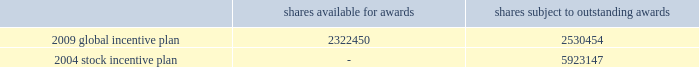Tax returns for 2001 and beyond are open for examination under statute .
Currently , unrecognized tax benefits are not expected to change significantly over the next 12 months .
19 .
Stock-based and other management compensation plans in april 2009 , the company approved a global incentive plan which replaces the company 2019s 2004 stock incentive plan .
The 2009 global incentive plan ( 201cgip 201d ) enables the compensation committee of the board of directors to award incentive and nonqualified stock options , stock appreciation rights , shares of series a common stock , restricted stock , restricted stock units ( 201crsus 201d ) and incentive bonuses ( which may be paid in cash or stock or a combination thereof ) , any of which may be performance-based , with vesting and other award provisions that provide effective incentive to company employees ( including officers ) , non-management directors and other service providers .
Under the 2009 gip , the company no longer can grant rsus with the right to participate in dividends or dividend equivalents .
The maximum number of shares that may be issued under the 2009 gip is equal to 5350000 shares plus ( a ) any shares of series a common stock that remain available for issuance under the 2004 stock incentive plan ( 201csip 201d ) ( not including any shares of series a common stock that are subject to outstanding awards under the 2004 sip or any shares of series a common stock that were issued pursuant to awards under the 2004 sip ) and ( b ) any awards under the 2004 stock incentive plan that remain outstanding that cease for any reason to be subject to such awards ( other than by reason of exercise or settlement of the award to the extent that such award is exercised for or settled in vested and non-forfeitable shares ) .
As of december 31 , 2010 , total shares available for awards and total shares subject to outstanding awards are as follows : shares available for awards shares subject to outstanding awards .
Upon the termination of a participant 2019s employment with the company by reason of death or disability or by the company without cause ( as defined in the respective award agreements ) , an award in amount equal to ( i ) the value of the award granted multiplied by ( ii ) a fraction , ( x ) the numerator of which is the number of full months between grant date and the date of such termination , and ( y ) the denominator of which is the term of the award , such product to be rounded down to the nearest whole number , and reduced by ( iii ) the value of any award that previously vested , shall immediately vest and become payable to the participant .
Upon the termination of a participant 2019s employment with the company for any other reason , any unvested portion of the award shall be forfeited and cancelled without consideration .
There was $ 19 million and $ 0 million of tax benefit realized from stock option exercises and vesting of rsus during the years ended december 31 , 2010 and 2009 , respectively .
During the year ended december 31 , 2008 the company reversed $ 8 million of the $ 19 million tax benefit that was realized during the year ended december 31 , 2007 .
Deferred compensation in april 2007 , certain participants in the company 2019s 2004 deferred compensation plan elected to participate in a revised program , which includes both cash awards and restricted stock units ( see restricted stock units below ) .
Based on participation in the revised program , the company expensed $ 9 million , $ 10 million and $ 8 million during the years ended december 31 , 2010 , 2009 and 2008 , respectively , related to the revised program and made payments of $ 4 million during the year ended december 31 , 2010 to participants who left the company and $ 28 million to active employees during december 2010 .
As of december 31 , 2010 , $ 1 million remains to be paid during 2011 under the revised program .
As of december 31 , 2009 , there was no deferred compensation payable remaining associated with the 2004 deferred compensation plan .
The company recorded expense related to participants continuing in the 2004 deferred %%transmsg*** transmitting job : d77691 pcn : 132000000 ***%%pcmsg|132 |00011|yes|no|02/09/2011 18:22|0|0|page is valid , no graphics -- color : n| .
What portion of the total shares subject to outstanding awards is under the 2009 global incentive plan? 
Computations: (5923147 / (2530454 + 5923147))
Answer: 0.70067. 